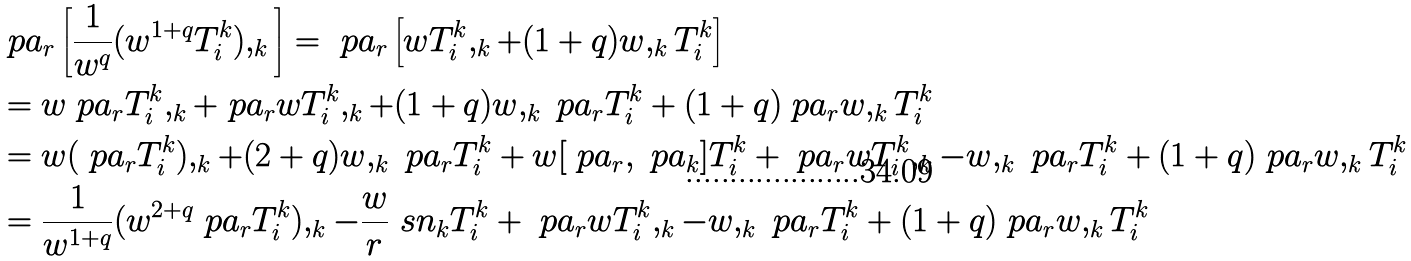Convert formula to latex. <formula><loc_0><loc_0><loc_500><loc_500>& \ p a _ { r } \left [ \frac { 1 } { w ^ { q } } ( w ^ { 1 + q } { T } ^ { k } _ { i } ) , _ { k } \right ] = \ p a _ { r } \left [ w { T } ^ { k } _ { i } , _ { k } + ( 1 + q ) w , _ { k } { T } ^ { k } _ { i } \right ] \\ & = w \ p a _ { r } { T } ^ { k } _ { i } , _ { k } + \ p a _ { r } w { T } ^ { k } _ { i } , _ { k } + ( 1 + q ) w , _ { k } \ p a _ { r } { T } ^ { k } _ { i } + ( 1 + q ) \ p a _ { r } w , _ { k } { T } ^ { k } _ { i } \\ & = w ( \ p a _ { r } { T } ^ { k } _ { i } ) , _ { k } + ( 2 + q ) w , _ { k } \ p a _ { r } { T } ^ { k } _ { i } + w [ \ p a _ { r } , \ p a _ { k } ] { T } ^ { k } _ { i } + \ p a _ { r } w { T } ^ { k } _ { i } , _ { k } - w , _ { k } \ p a _ { r } { T } ^ { k } _ { i } + ( 1 + q ) \ p a _ { r } w , _ { k } { T } ^ { k } _ { i } \\ & = \frac { 1 } { w ^ { 1 + q } } ( w ^ { 2 + q } \ p a _ { r } { T } ^ { k } _ { i } ) , _ { k } - \frac { w } { r } \ s n _ { k } { T } ^ { k } _ { i } + \ p a _ { r } w { T } ^ { k } _ { i } , _ { k } - w , _ { k } \ p a _ { r } { T } ^ { k } _ { i } + ( 1 + q ) \ p a _ { r } w , _ { k } { T } ^ { k } _ { i }</formula> 